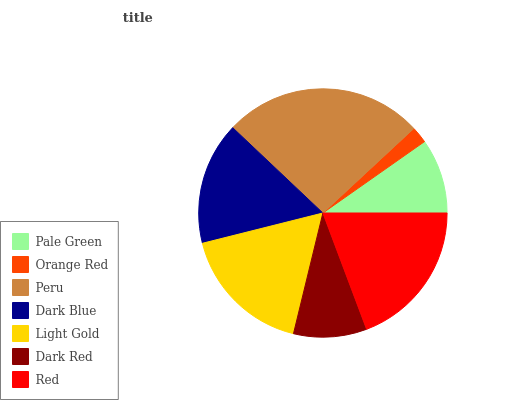Is Orange Red the minimum?
Answer yes or no. Yes. Is Peru the maximum?
Answer yes or no. Yes. Is Peru the minimum?
Answer yes or no. No. Is Orange Red the maximum?
Answer yes or no. No. Is Peru greater than Orange Red?
Answer yes or no. Yes. Is Orange Red less than Peru?
Answer yes or no. Yes. Is Orange Red greater than Peru?
Answer yes or no. No. Is Peru less than Orange Red?
Answer yes or no. No. Is Dark Blue the high median?
Answer yes or no. Yes. Is Dark Blue the low median?
Answer yes or no. Yes. Is Peru the high median?
Answer yes or no. No. Is Peru the low median?
Answer yes or no. No. 